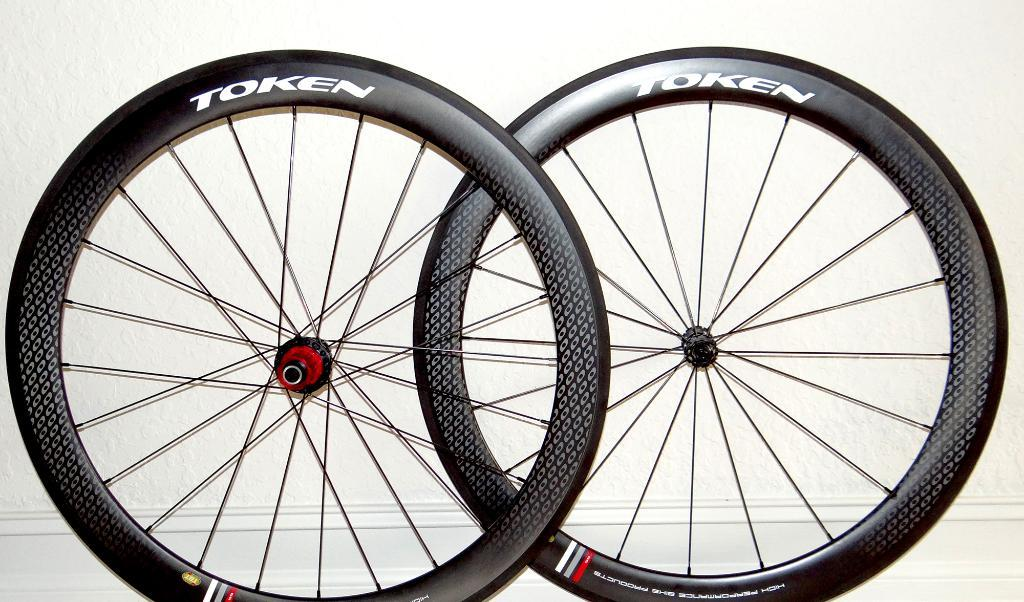What objects are present in the image? There are two tires in the image. What is written on the tires? The tires have "token" written on them. What color is the background of the image? The background of the image is white. What type of soap is being used to clean the wall in the image? There is no soap or wall present in the image; it only features two tires with "token" written on them against a white background. 